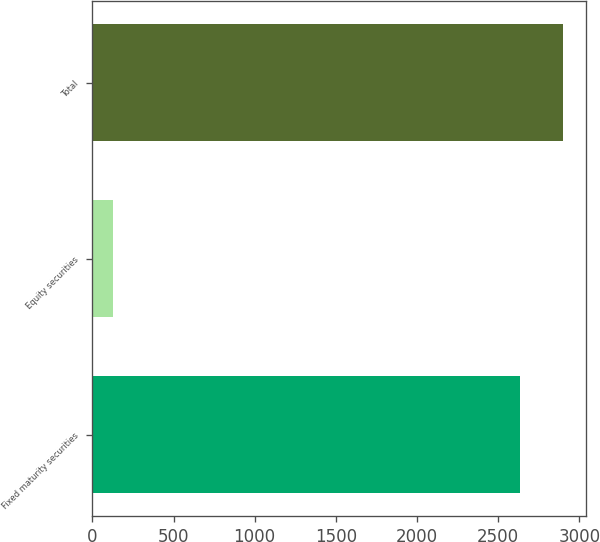Convert chart. <chart><loc_0><loc_0><loc_500><loc_500><bar_chart><fcel>Fixed maturity securities<fcel>Equity securities<fcel>Total<nl><fcel>2634<fcel>130<fcel>2897.4<nl></chart> 